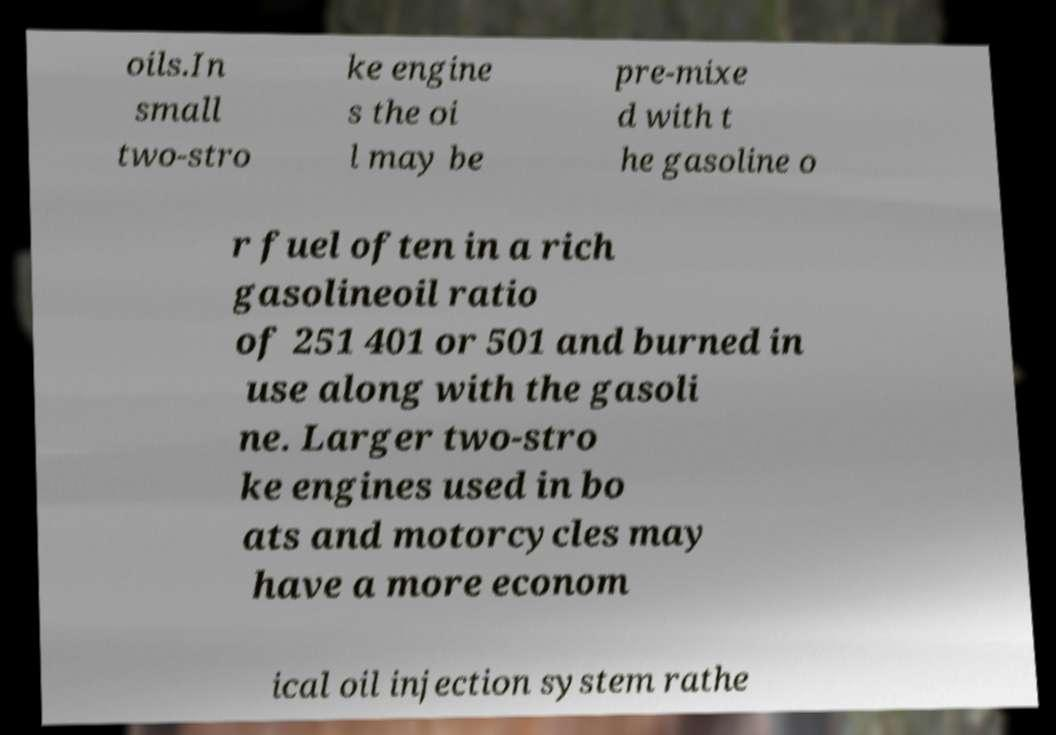Can you read and provide the text displayed in the image?This photo seems to have some interesting text. Can you extract and type it out for me? oils.In small two-stro ke engine s the oi l may be pre-mixe d with t he gasoline o r fuel often in a rich gasolineoil ratio of 251 401 or 501 and burned in use along with the gasoli ne. Larger two-stro ke engines used in bo ats and motorcycles may have a more econom ical oil injection system rathe 